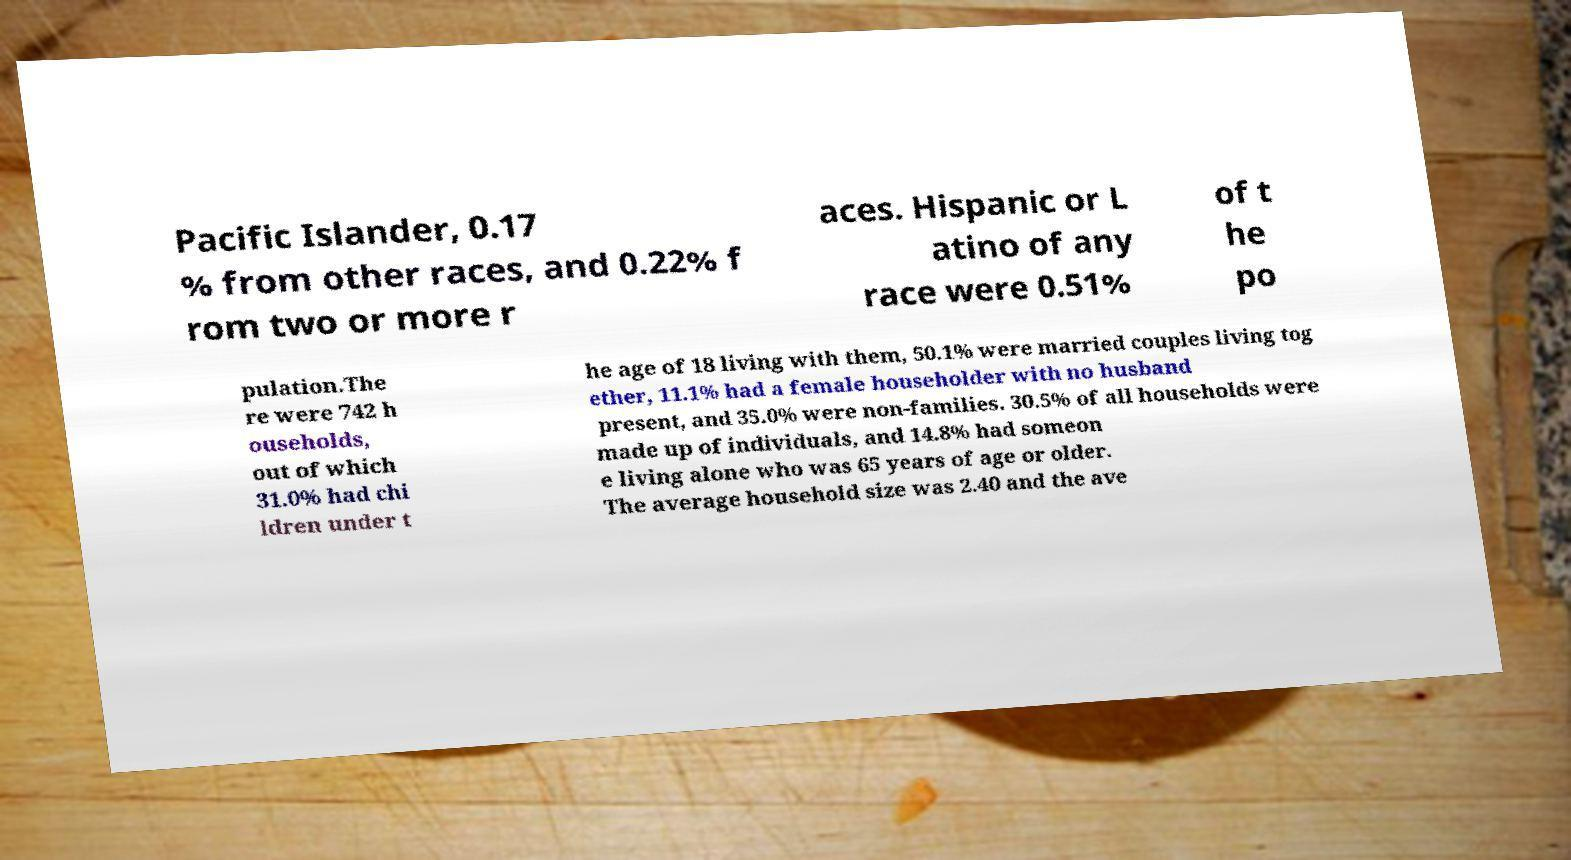Could you assist in decoding the text presented in this image and type it out clearly? Pacific Islander, 0.17 % from other races, and 0.22% f rom two or more r aces. Hispanic or L atino of any race were 0.51% of t he po pulation.The re were 742 h ouseholds, out of which 31.0% had chi ldren under t he age of 18 living with them, 50.1% were married couples living tog ether, 11.1% had a female householder with no husband present, and 35.0% were non-families. 30.5% of all households were made up of individuals, and 14.8% had someon e living alone who was 65 years of age or older. The average household size was 2.40 and the ave 